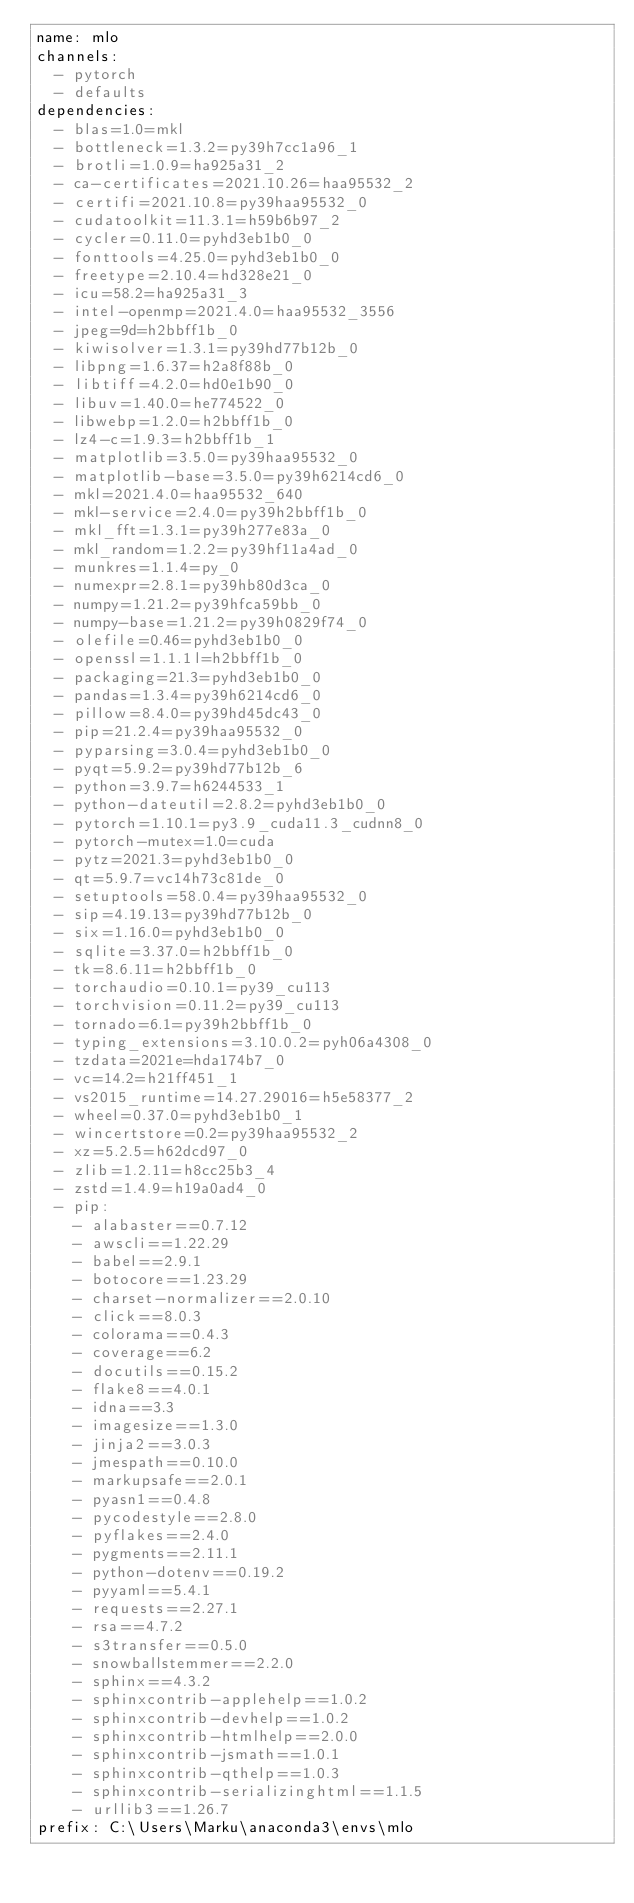<code> <loc_0><loc_0><loc_500><loc_500><_YAML_>name: mlo
channels:
  - pytorch
  - defaults
dependencies:
  - blas=1.0=mkl
  - bottleneck=1.3.2=py39h7cc1a96_1
  - brotli=1.0.9=ha925a31_2
  - ca-certificates=2021.10.26=haa95532_2
  - certifi=2021.10.8=py39haa95532_0
  - cudatoolkit=11.3.1=h59b6b97_2
  - cycler=0.11.0=pyhd3eb1b0_0
  - fonttools=4.25.0=pyhd3eb1b0_0
  - freetype=2.10.4=hd328e21_0
  - icu=58.2=ha925a31_3
  - intel-openmp=2021.4.0=haa95532_3556
  - jpeg=9d=h2bbff1b_0
  - kiwisolver=1.3.1=py39hd77b12b_0
  - libpng=1.6.37=h2a8f88b_0
  - libtiff=4.2.0=hd0e1b90_0
  - libuv=1.40.0=he774522_0
  - libwebp=1.2.0=h2bbff1b_0
  - lz4-c=1.9.3=h2bbff1b_1
  - matplotlib=3.5.0=py39haa95532_0
  - matplotlib-base=3.5.0=py39h6214cd6_0
  - mkl=2021.4.0=haa95532_640
  - mkl-service=2.4.0=py39h2bbff1b_0
  - mkl_fft=1.3.1=py39h277e83a_0
  - mkl_random=1.2.2=py39hf11a4ad_0
  - munkres=1.1.4=py_0
  - numexpr=2.8.1=py39hb80d3ca_0
  - numpy=1.21.2=py39hfca59bb_0
  - numpy-base=1.21.2=py39h0829f74_0
  - olefile=0.46=pyhd3eb1b0_0
  - openssl=1.1.1l=h2bbff1b_0
  - packaging=21.3=pyhd3eb1b0_0
  - pandas=1.3.4=py39h6214cd6_0
  - pillow=8.4.0=py39hd45dc43_0
  - pip=21.2.4=py39haa95532_0
  - pyparsing=3.0.4=pyhd3eb1b0_0
  - pyqt=5.9.2=py39hd77b12b_6
  - python=3.9.7=h6244533_1
  - python-dateutil=2.8.2=pyhd3eb1b0_0
  - pytorch=1.10.1=py3.9_cuda11.3_cudnn8_0
  - pytorch-mutex=1.0=cuda
  - pytz=2021.3=pyhd3eb1b0_0
  - qt=5.9.7=vc14h73c81de_0
  - setuptools=58.0.4=py39haa95532_0
  - sip=4.19.13=py39hd77b12b_0
  - six=1.16.0=pyhd3eb1b0_0
  - sqlite=3.37.0=h2bbff1b_0
  - tk=8.6.11=h2bbff1b_0
  - torchaudio=0.10.1=py39_cu113
  - torchvision=0.11.2=py39_cu113
  - tornado=6.1=py39h2bbff1b_0
  - typing_extensions=3.10.0.2=pyh06a4308_0
  - tzdata=2021e=hda174b7_0
  - vc=14.2=h21ff451_1
  - vs2015_runtime=14.27.29016=h5e58377_2
  - wheel=0.37.0=pyhd3eb1b0_1
  - wincertstore=0.2=py39haa95532_2
  - xz=5.2.5=h62dcd97_0
  - zlib=1.2.11=h8cc25b3_4
  - zstd=1.4.9=h19a0ad4_0
  - pip:
    - alabaster==0.7.12
    - awscli==1.22.29
    - babel==2.9.1
    - botocore==1.23.29
    - charset-normalizer==2.0.10
    - click==8.0.3
    - colorama==0.4.3
    - coverage==6.2
    - docutils==0.15.2
    - flake8==4.0.1
    - idna==3.3
    - imagesize==1.3.0
    - jinja2==3.0.3
    - jmespath==0.10.0
    - markupsafe==2.0.1
    - pyasn1==0.4.8
    - pycodestyle==2.8.0
    - pyflakes==2.4.0
    - pygments==2.11.1
    - python-dotenv==0.19.2
    - pyyaml==5.4.1
    - requests==2.27.1
    - rsa==4.7.2
    - s3transfer==0.5.0
    - snowballstemmer==2.2.0
    - sphinx==4.3.2
    - sphinxcontrib-applehelp==1.0.2
    - sphinxcontrib-devhelp==1.0.2
    - sphinxcontrib-htmlhelp==2.0.0
    - sphinxcontrib-jsmath==1.0.1
    - sphinxcontrib-qthelp==1.0.3
    - sphinxcontrib-serializinghtml==1.1.5
    - urllib3==1.26.7
prefix: C:\Users\Marku\anaconda3\envs\mlo
</code> 